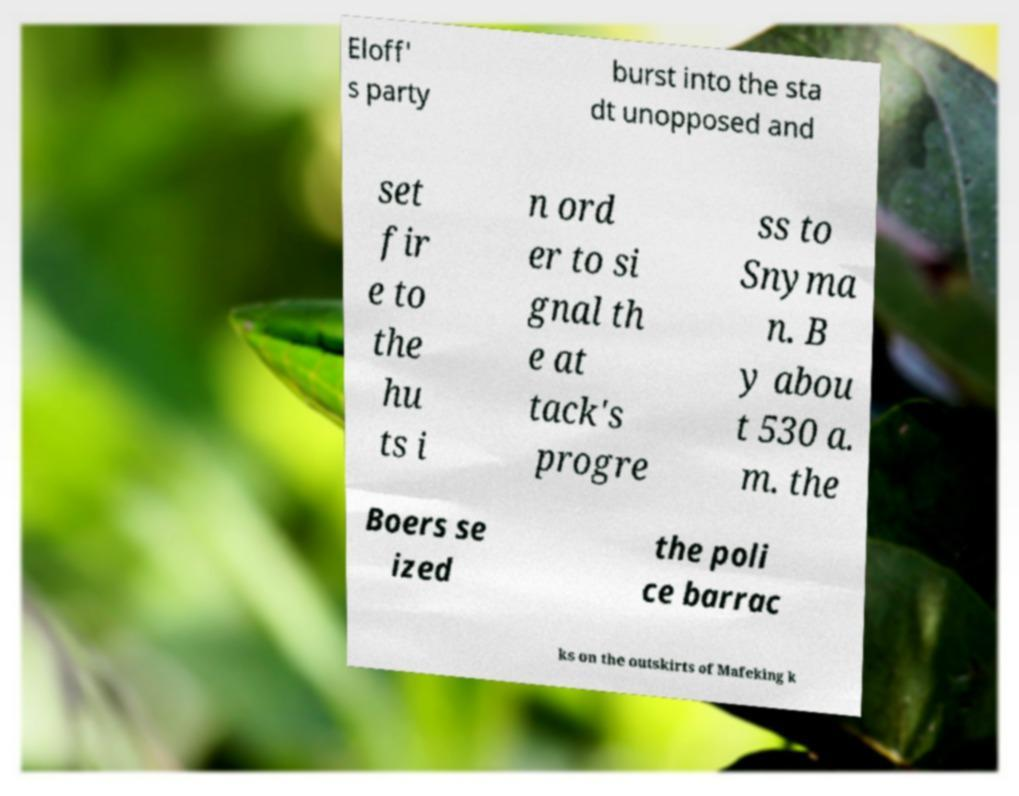Could you extract and type out the text from this image? Eloff' s party burst into the sta dt unopposed and set fir e to the hu ts i n ord er to si gnal th e at tack's progre ss to Snyma n. B y abou t 530 a. m. the Boers se ized the poli ce barrac ks on the outskirts of Mafeking k 